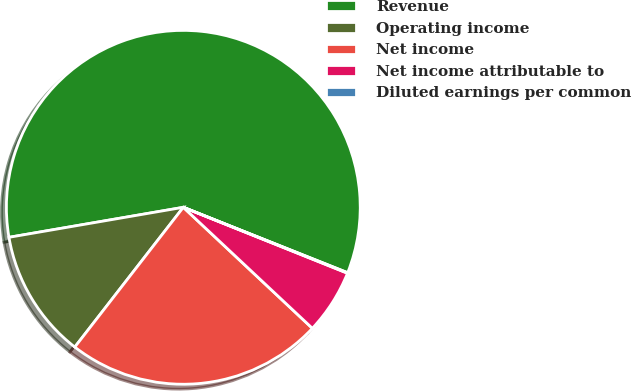<chart> <loc_0><loc_0><loc_500><loc_500><pie_chart><fcel>Revenue<fcel>Operating income<fcel>Net income<fcel>Net income attributable to<fcel>Diluted earnings per common<nl><fcel>58.74%<fcel>11.78%<fcel>23.52%<fcel>5.91%<fcel>0.05%<nl></chart> 